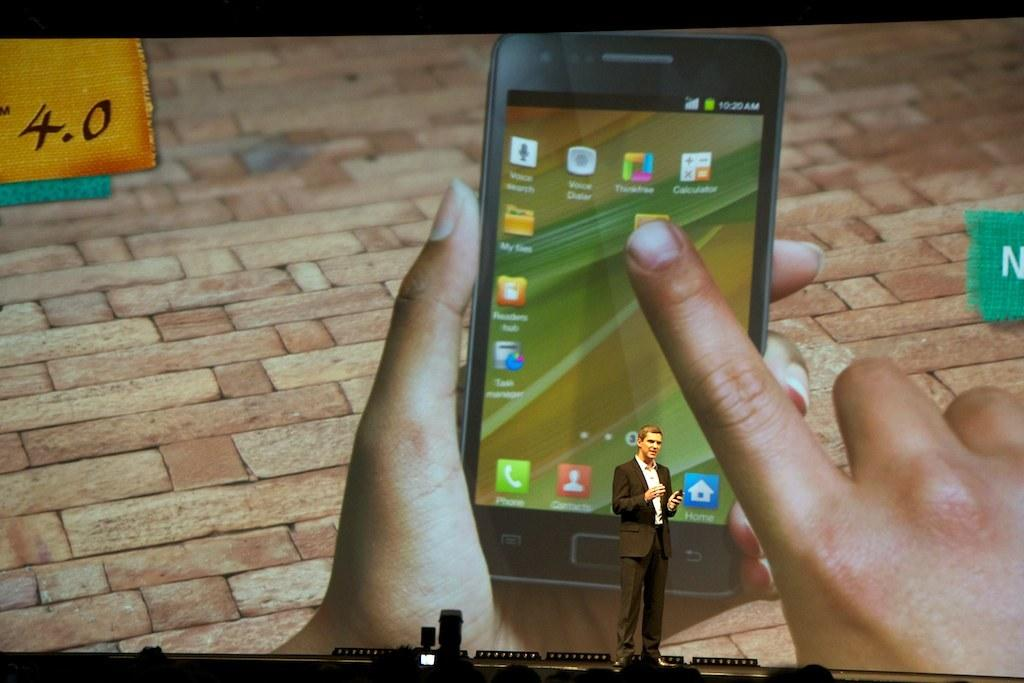<image>
Summarize the visual content of the image. a man in front of a large screen with the numbers 4.0 and a cell phone on it 